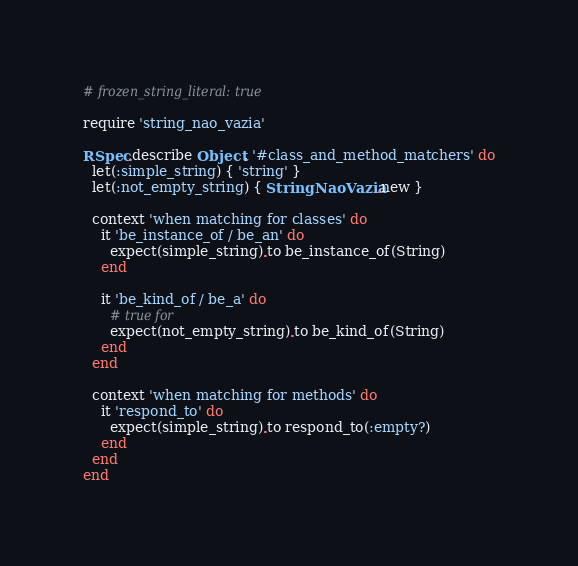Convert code to text. <code><loc_0><loc_0><loc_500><loc_500><_Ruby_># frozen_string_literal: true

require 'string_nao_vazia'

RSpec.describe Object, '#class_and_method_matchers' do
  let(:simple_string) { 'string' }
  let(:not_empty_string) { StringNaoVazia.new }

  context 'when matching for classes' do
    it 'be_instance_of / be_an' do
      expect(simple_string).to be_instance_of(String)
    end

    it 'be_kind_of / be_a' do
      # true for
      expect(not_empty_string).to be_kind_of(String)
    end
  end

  context 'when matching for methods' do
    it 'respond_to' do
      expect(simple_string).to respond_to(:empty?)
    end
  end
end
</code> 